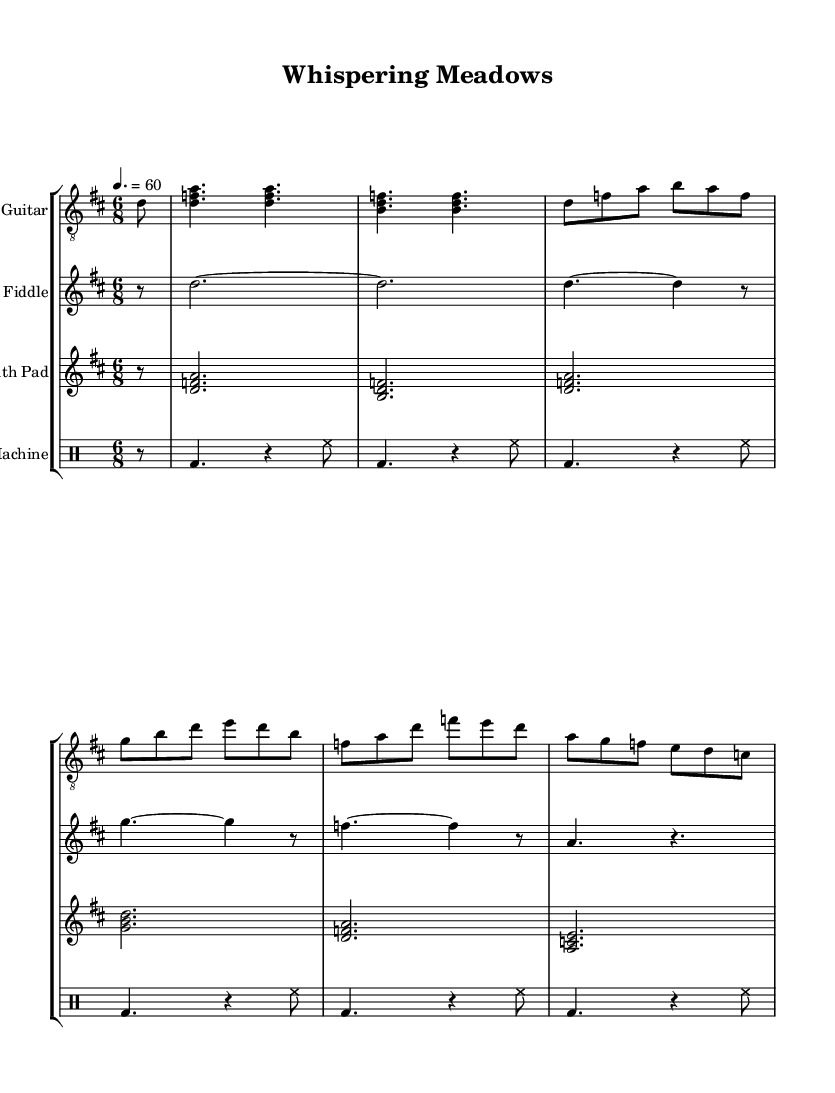What is the key signature of this music? The key signature is D major, which has two sharps: F# and C#. This can be determined by looking at the key signature indication at the beginning of the music.
Answer: D major What is the time signature of this music? The time signature is 6/8, indicated at the beginning of the score. It shows that there are six eighth notes in each measure.
Answer: 6/8 What is the tempo marking? The tempo marking is 60 beats per minute, as indicated by the tempo text that specifies the speed of the piece. This is found after the time signature notation.
Answer: 60 How many measures does the acoustic guitar section have? The acoustic guitar section contains eight measures, which can be counted by looking at the bar lines in that staff.
Answer: 8 What type of instruments are featured in this piece? The piece features acoustic guitar, fiddle, synth pad, and a drum machine. This can be confirmed by the instrument labels at the beginning of each staff in the score.
Answer: Acoustic guitar, fiddle, synth pad, drum machine Which instrument plays the first note? The first note is played by the acoustic guitar, as it is the first staff listed and starts the piece. You can see the initial note after the partial bar rest.
Answer: Acoustic guitar What is the rhythmic structure of the drum machine part? The drum machine part has a 4/4 rhythm with a consistent pattern of bass drum and hi-hat notes, indicated in the drum staff throughout the measures.
Answer: 4/4 rhythm 